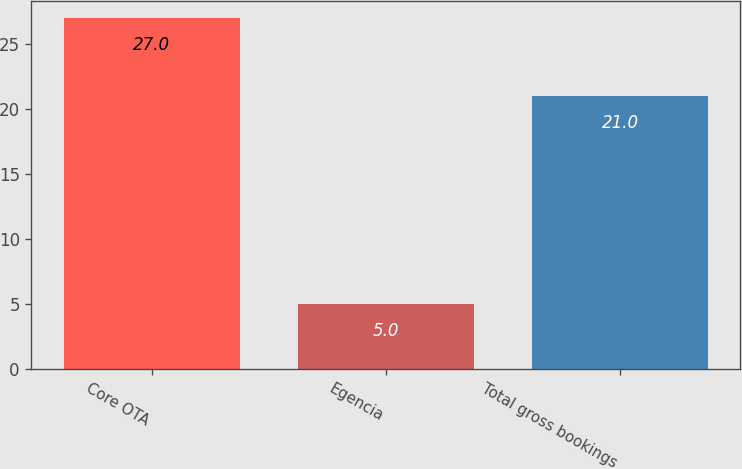Convert chart. <chart><loc_0><loc_0><loc_500><loc_500><bar_chart><fcel>Core OTA<fcel>Egencia<fcel>Total gross bookings<nl><fcel>27<fcel>5<fcel>21<nl></chart> 